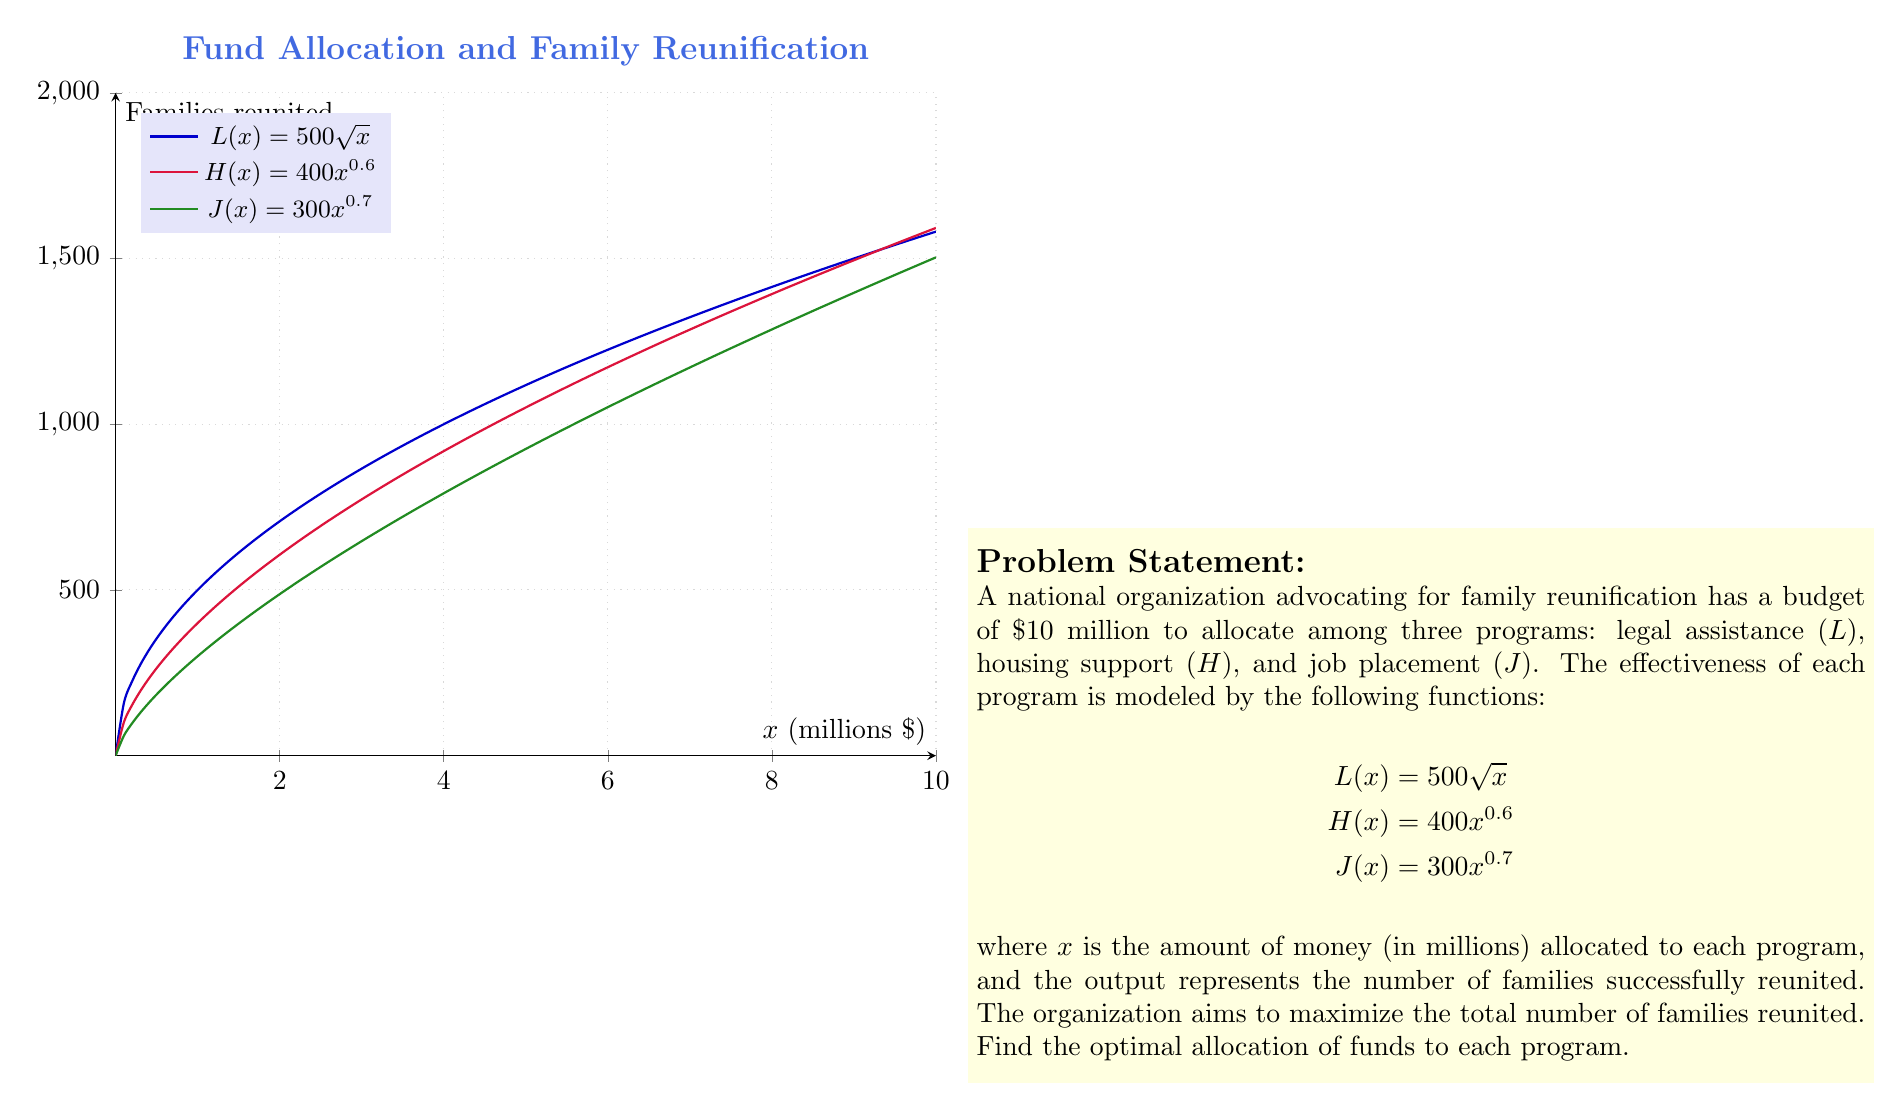Give your solution to this math problem. To solve this optimization problem, we'll use the method of Lagrange multipliers:

1) Let $x$, $y$, and $z$ be the amounts allocated to L, H, and J respectively. Our objective function is:

   $$f(x,y,z) = 500\sqrt{x} + 400y^{0.6} + 300z^{0.7}$$

2) The constraint is:

   $$g(x,y,z) = x + y + z - 10 = 0$$

3) Form the Lagrangian:

   $$\mathcal{L}(x,y,z,\lambda) = 500\sqrt{x} + 400y^{0.6} + 300z^{0.7} - \lambda(x + y + z - 10)$$

4) Set partial derivatives to zero:

   $$\begin{align*}
   \frac{\partial \mathcal{L}}{\partial x} &= \frac{250}{\sqrt{x}} - \lambda = 0 \\
   \frac{\partial \mathcal{L}}{\partial y} &= 240y^{-0.4} - \lambda = 0 \\
   \frac{\partial \mathcal{L}}{\partial z} &= 210z^{-0.3} - \lambda = 0 \\
   \frac{\partial \mathcal{L}}{\partial \lambda} &= x + y + z - 10 = 0
   \end{align*}$$

5) From these equations:

   $$\begin{align*}
   x &= \frac{62500}{\lambda^2} \\
   y &= \left(\frac{240}{\lambda}\right)^{5/3} \\
   z &= \left(\frac{210}{\lambda}\right)^{10/7}
   \end{align*}$$

6) Substitute into the constraint equation:

   $$\frac{62500}{\lambda^2} + \left(\frac{240}{\lambda}\right)^{5/3} + \left(\frac{210}{\lambda}\right)^{10/7} = 10$$

7) Solve this equation numerically to get $\lambda \approx 157.7321$

8) Substitute back to get:

   $$\begin{align*}
   x &\approx 2.5114 \\
   y &\approx 3.7671 \\
   z &\approx 3.7215
   \end{align*}$$

Therefore, the optimal allocation is approximately $2.5114 million to legal assistance, $3.7671 million to housing support, and $3.7215 million to job placement.
Answer: L: $2.5114 million, H: $3.7671 million, J: $3.7215 million 